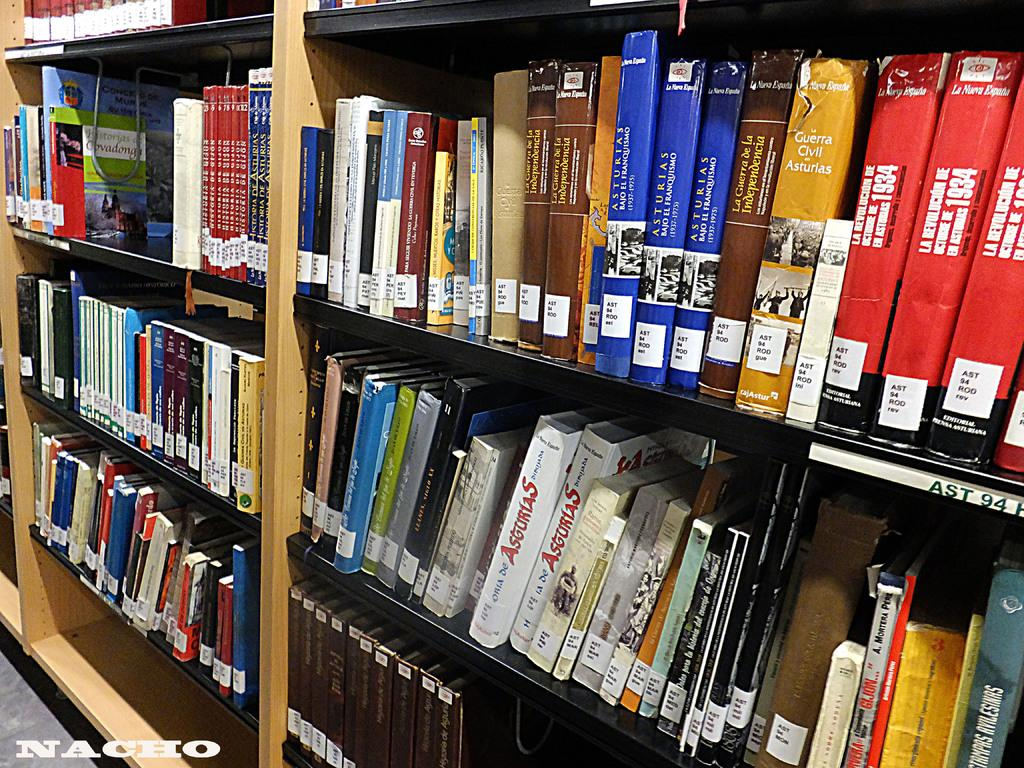Provide a one-sentence caption for the provided image. Three copies of a tall blue book titled Asturias sit on a library shelf. 